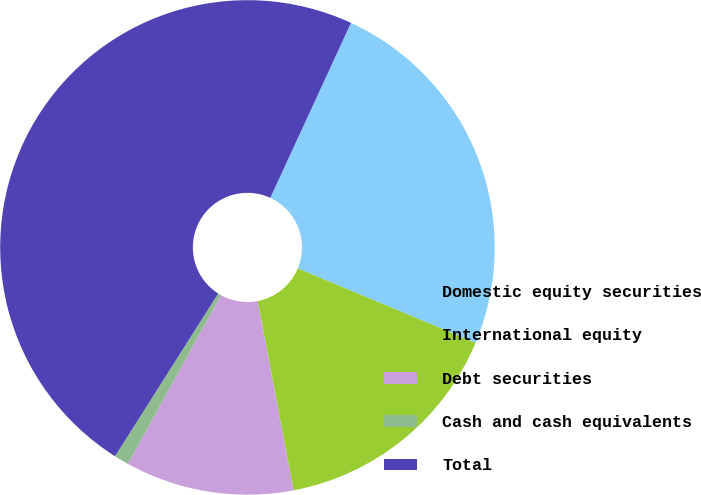Convert chart to OTSL. <chart><loc_0><loc_0><loc_500><loc_500><pie_chart><fcel>Domestic equity securities<fcel>International equity<fcel>Debt securities<fcel>Cash and cash equivalents<fcel>Total<nl><fcel>24.43%<fcel>15.71%<fcel>11.02%<fcel>0.96%<fcel>47.89%<nl></chart> 